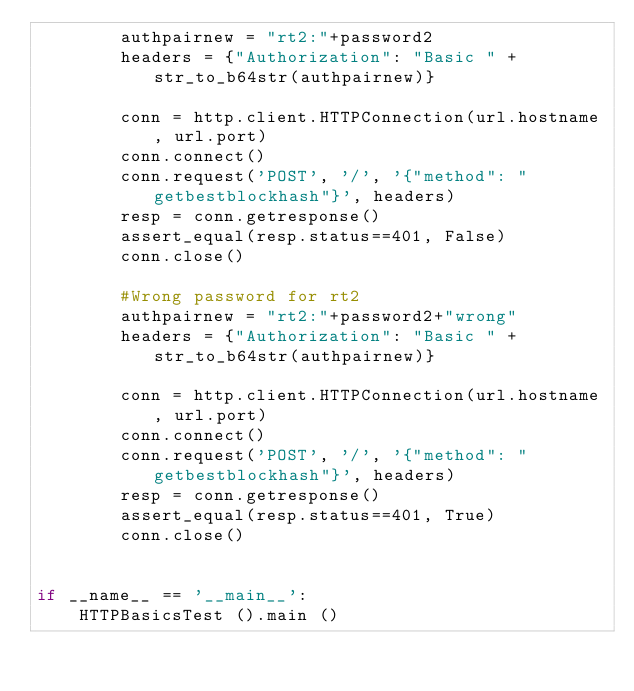Convert code to text. <code><loc_0><loc_0><loc_500><loc_500><_Python_>        authpairnew = "rt2:"+password2
        headers = {"Authorization": "Basic " + str_to_b64str(authpairnew)}

        conn = http.client.HTTPConnection(url.hostname, url.port)
        conn.connect()
        conn.request('POST', '/', '{"method": "getbestblockhash"}', headers)
        resp = conn.getresponse()
        assert_equal(resp.status==401, False)
        conn.close()

        #Wrong password for rt2
        authpairnew = "rt2:"+password2+"wrong"
        headers = {"Authorization": "Basic " + str_to_b64str(authpairnew)}

        conn = http.client.HTTPConnection(url.hostname, url.port)
        conn.connect()
        conn.request('POST', '/', '{"method": "getbestblockhash"}', headers)
        resp = conn.getresponse()
        assert_equal(resp.status==401, True)
        conn.close()


if __name__ == '__main__':
    HTTPBasicsTest ().main ()
</code> 